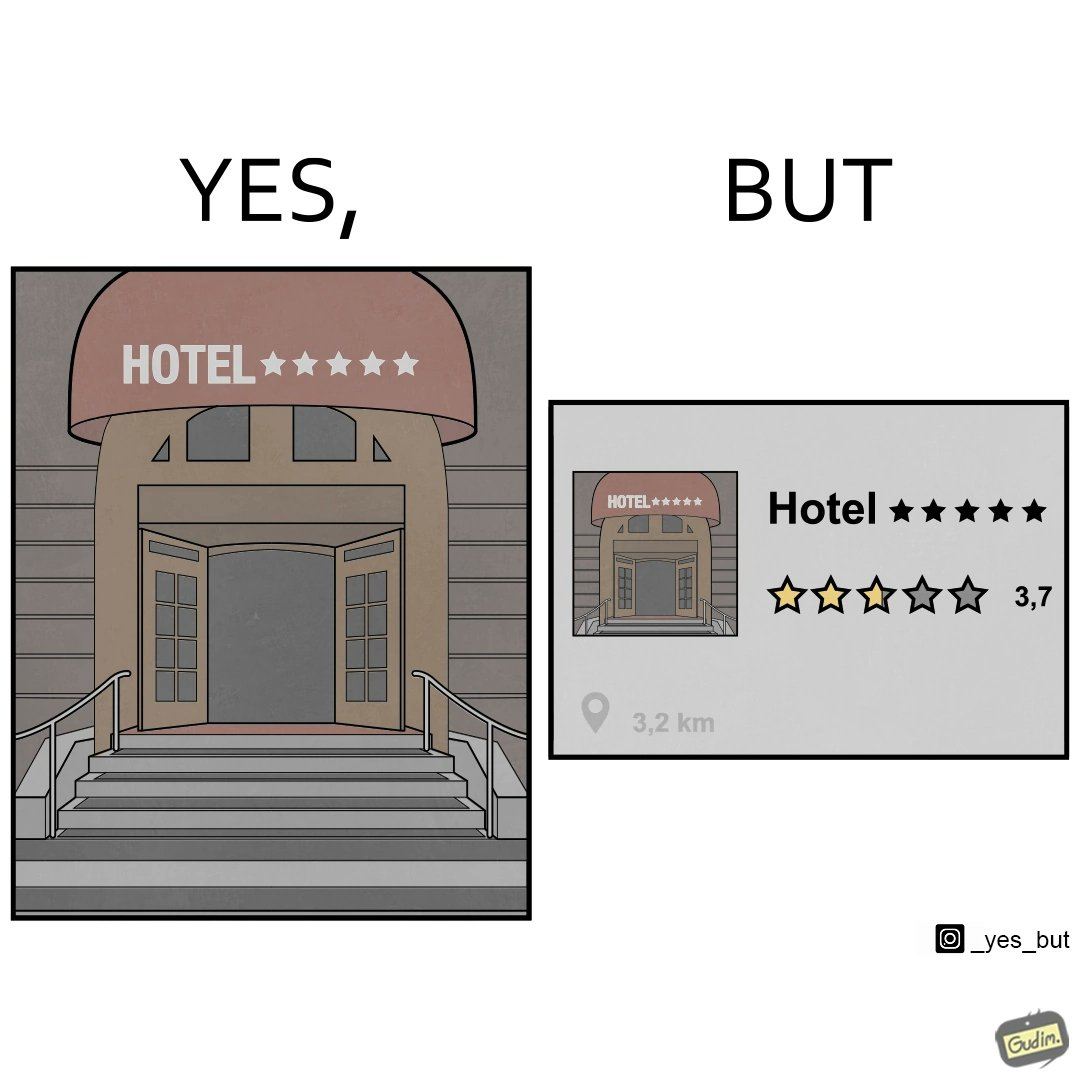Explain why this image is satirical. The image is funny because the Hotel's name suggests that it is very good and as it's name itself is Hotel 5 stars but in reality it received a rating of only 3.7 out of 5 